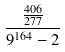<formula> <loc_0><loc_0><loc_500><loc_500>\frac { \frac { 4 0 6 } { 2 7 7 } } { 9 ^ { 1 6 4 } - 2 }</formula> 